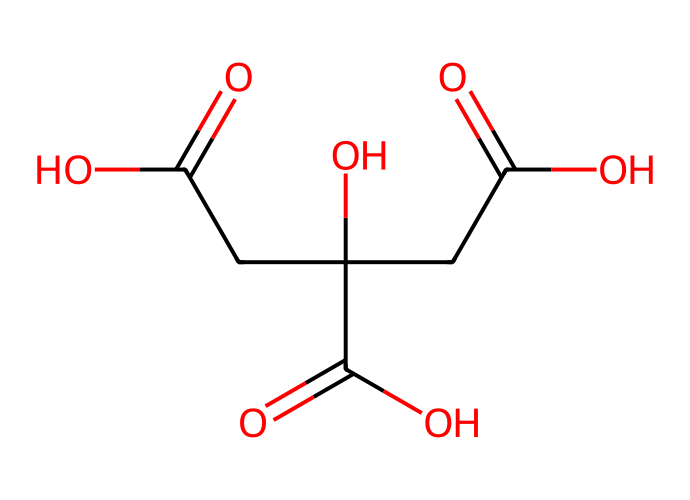What is the name of this acid? The SMILES representation indicates the presence of hydroxyl (−OH) and carboxyl (−COOH) functional groups, which are characteristic of acids. The structure represents citric acid, a common natural preservative.
Answer: citric acid How many carboxyl groups are present in this chemical? By examining the SMILES string, there are three distinct carboxyl (−COOH) groups indicated in the chemical structure, which contributes to the acidity of citric acid.
Answer: three What is the total number of carbon atoms in this acid? The SMILES depiction shows a total of six carbon atoms (C), as counted from the structure. This is determined by identifying each 'C' symbol in the representation.
Answer: six Does this acid have any hydroxyl groups? The presence of 'O' directly connected to 'C' indicates the presence of hydroxyl groups. The chemical structure indeed shows that there are one or more hydroxyl groups, confirming that citric acid is a hydroxy acid.
Answer: yes What is the pH characteristic of citric acid? Citric acid is known to be a weak acid, and upon dissociation in solution, it typically results in a pH range around 2 to 3, reflecting its acidic nature.
Answer: around 2 to 3 What is the primary use of citric acid in food? Citric acid is primarily used as a natural preservative in food and beverages to enhance flavor and prevent spoilage, especially in fruit juices.
Answer: preservative 